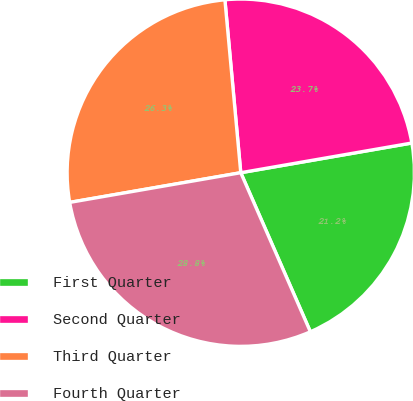Convert chart to OTSL. <chart><loc_0><loc_0><loc_500><loc_500><pie_chart><fcel>First Quarter<fcel>Second Quarter<fcel>Third Quarter<fcel>Fourth Quarter<nl><fcel>21.17%<fcel>23.72%<fcel>26.28%<fcel>28.83%<nl></chart> 